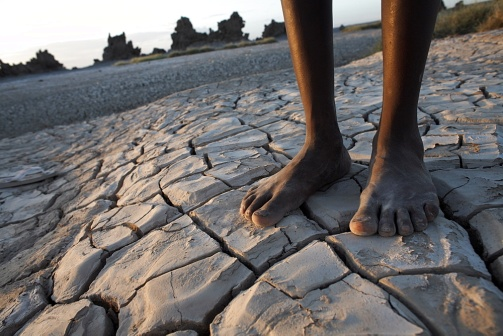Could you describe the climate indicated by this image? The photograph likely portrays an arid or semi-arid region, given the presence of extensive, dry cracks in the soil and sparse vegetation. The conditions suggest that the area experiences low rainfall, high temperatures, and possibly frequent droughts, leading to such parched landscapes. 